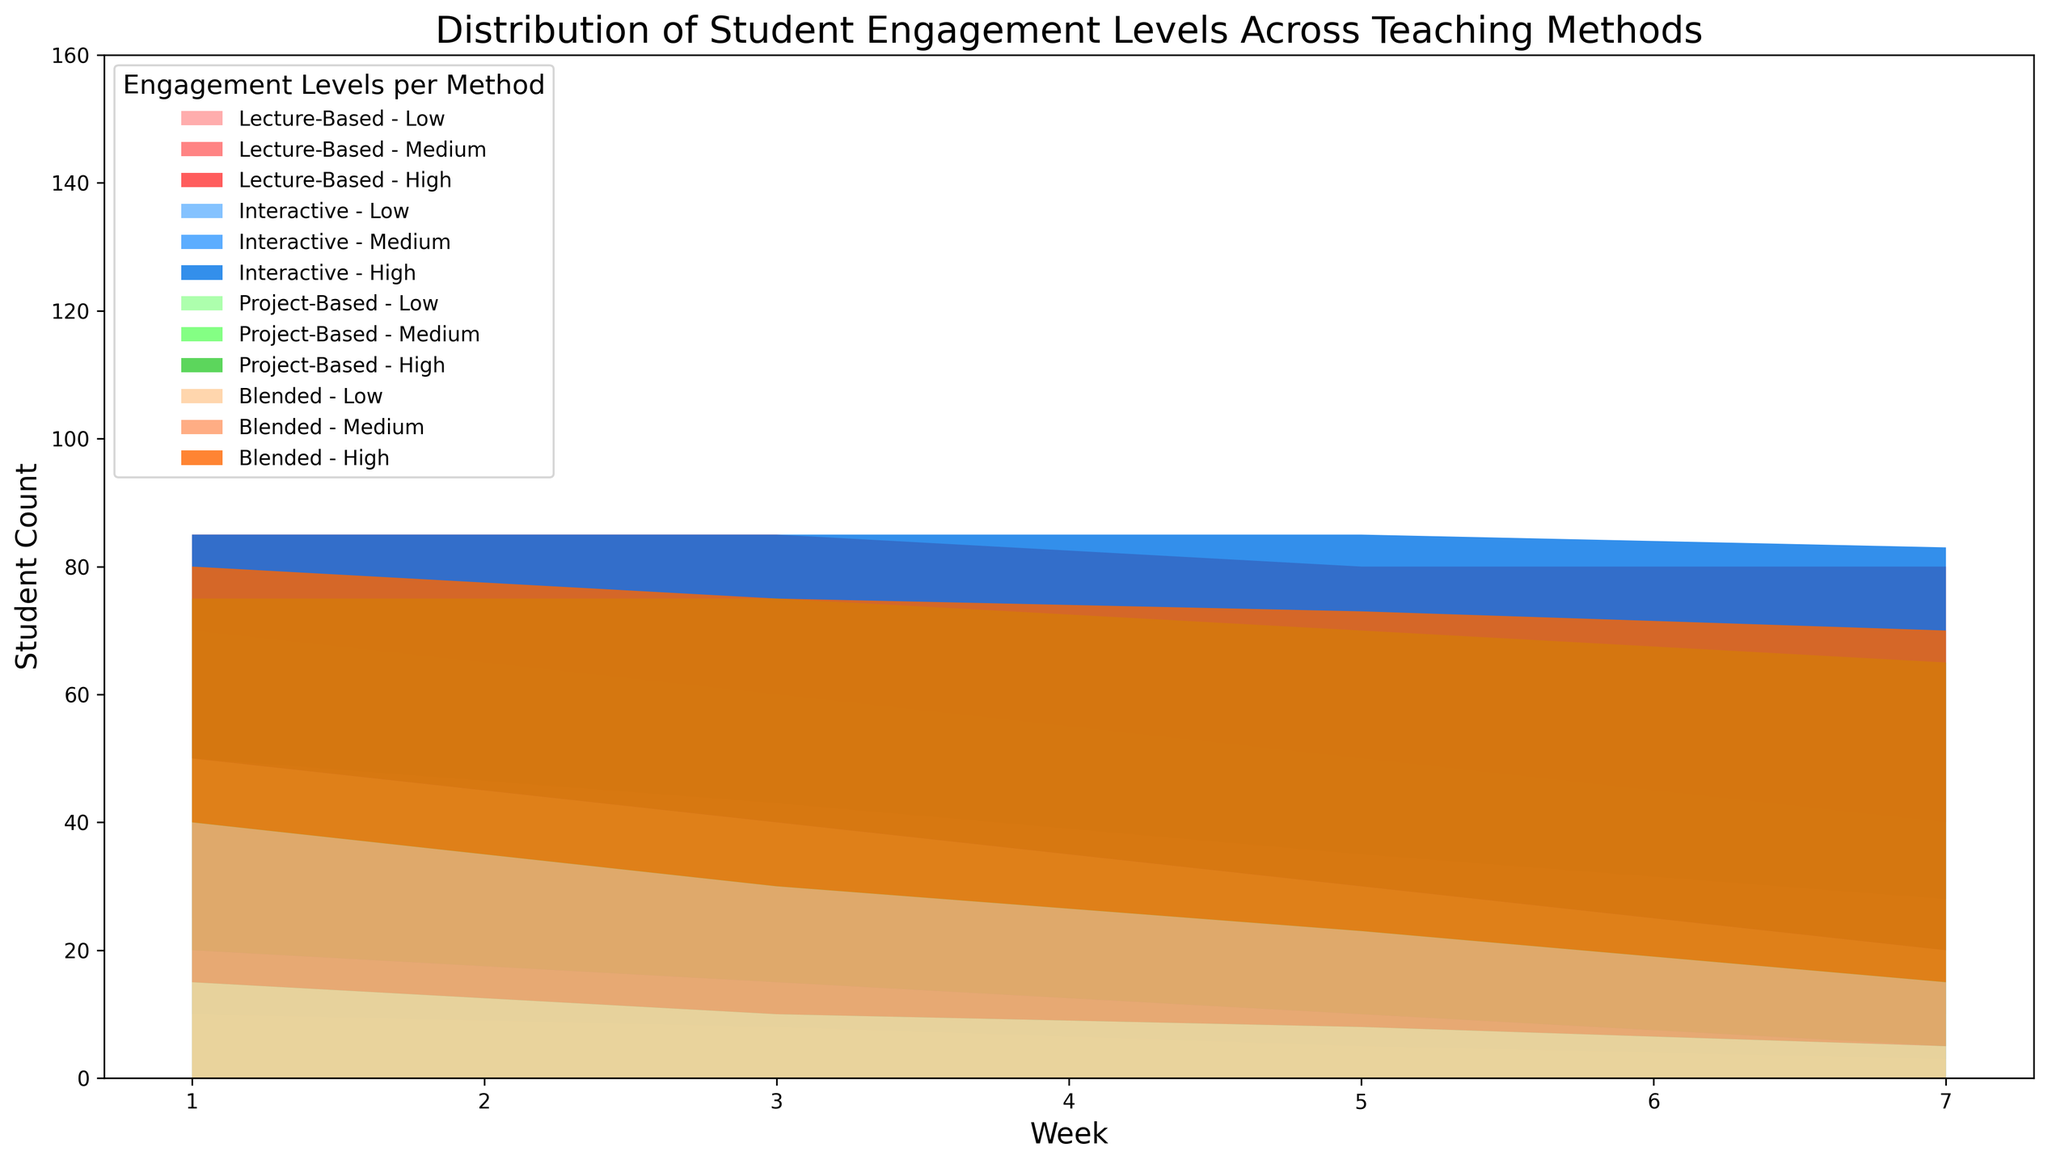What teaching method had the highest count of high engagement in Week 7? To answer this, observe which teaching method's area segment denoting 'High' is the tallest in Week 7. The 'High' segment in Week 7 for Interactive teaching is the tallest. Thus, Interactive teaching had the highest count of high engagement.
Answer: Interactive How did the count of low engagement change over the semester for Project-Based teaching? Observe the 'Low' segments for Project-Based teaching across Weeks 1, 3, 5, and 7. The counts are 20, 15, 10, and 5 respectively, showing a consistent decrease in low engagement over the semester.
Answer: Decreased In Week 5, which teaching method had the highest count of high engagement? Examine the 'High' engagement segment heights for Week 5 across all teaching methods. Interactive has the tallest 'High' segment in Week 5.
Answer: Interactive What's the difference in student count between High and Low engagement for Blended teaching in Week 1? By locating Week 1 for Blended teaching, note the student counts. High engagement has 40 students and Low engagement has 15 students. Subtracting these, the difference is 40 - 15 = 25.
Answer: 25 Compare Medium engagement counts between Lecture-Based and Blended teaching in Week 7. Which one is higher? Observe the 'Medium' segments for Lecture-Based and Blended teaching in Week 7. Lecture-Based has 30 students and Blended has 10 students, so Lecture-Based is higher.
Answer: Lecture-Based What trend is observed in the high engagement levels for Blended teaching over the weeks? Look at the 'High' segments for Blended teaching across the weeks: 40, 45, 50, and 55. High engagement increases consistently over the course of the semester.
Answer: Increasing Which teaching method showed a consistent decrease in low engagement levels over the weeks? Analyze the 'Low' segments for each teaching method over the weeks. Lecture-Based and Project-Based methods both show consistent decreases in low engagement levels over the weeks.
Answer: Lecture-Based, Project-Based Sum up the total high engagement counts for Interactive teaching over all weeks. Add the 'High' engagement numbers for Interactive teaching for Weeks 1, 3, 5, and 7: 35 + 42 + 50 + 55. Thus, the sum is 182.
Answer: 182 Which week shows the maximum total student engagement across all methods and levels? Add up the student counts for all engagement levels in each week. Week 7 has the highest total with noticeable taller and more area segments.
Answer: Week 7 